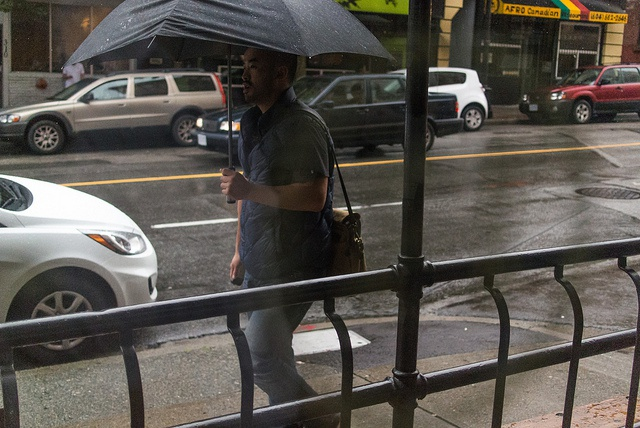Describe the objects in this image and their specific colors. I can see people in darkgreen, black, and gray tones, car in darkgreen, white, black, gray, and darkgray tones, umbrella in darkgreen, gray, and black tones, car in darkgreen, black, gray, darkgray, and lightgray tones, and car in darkgreen, black, and gray tones in this image. 